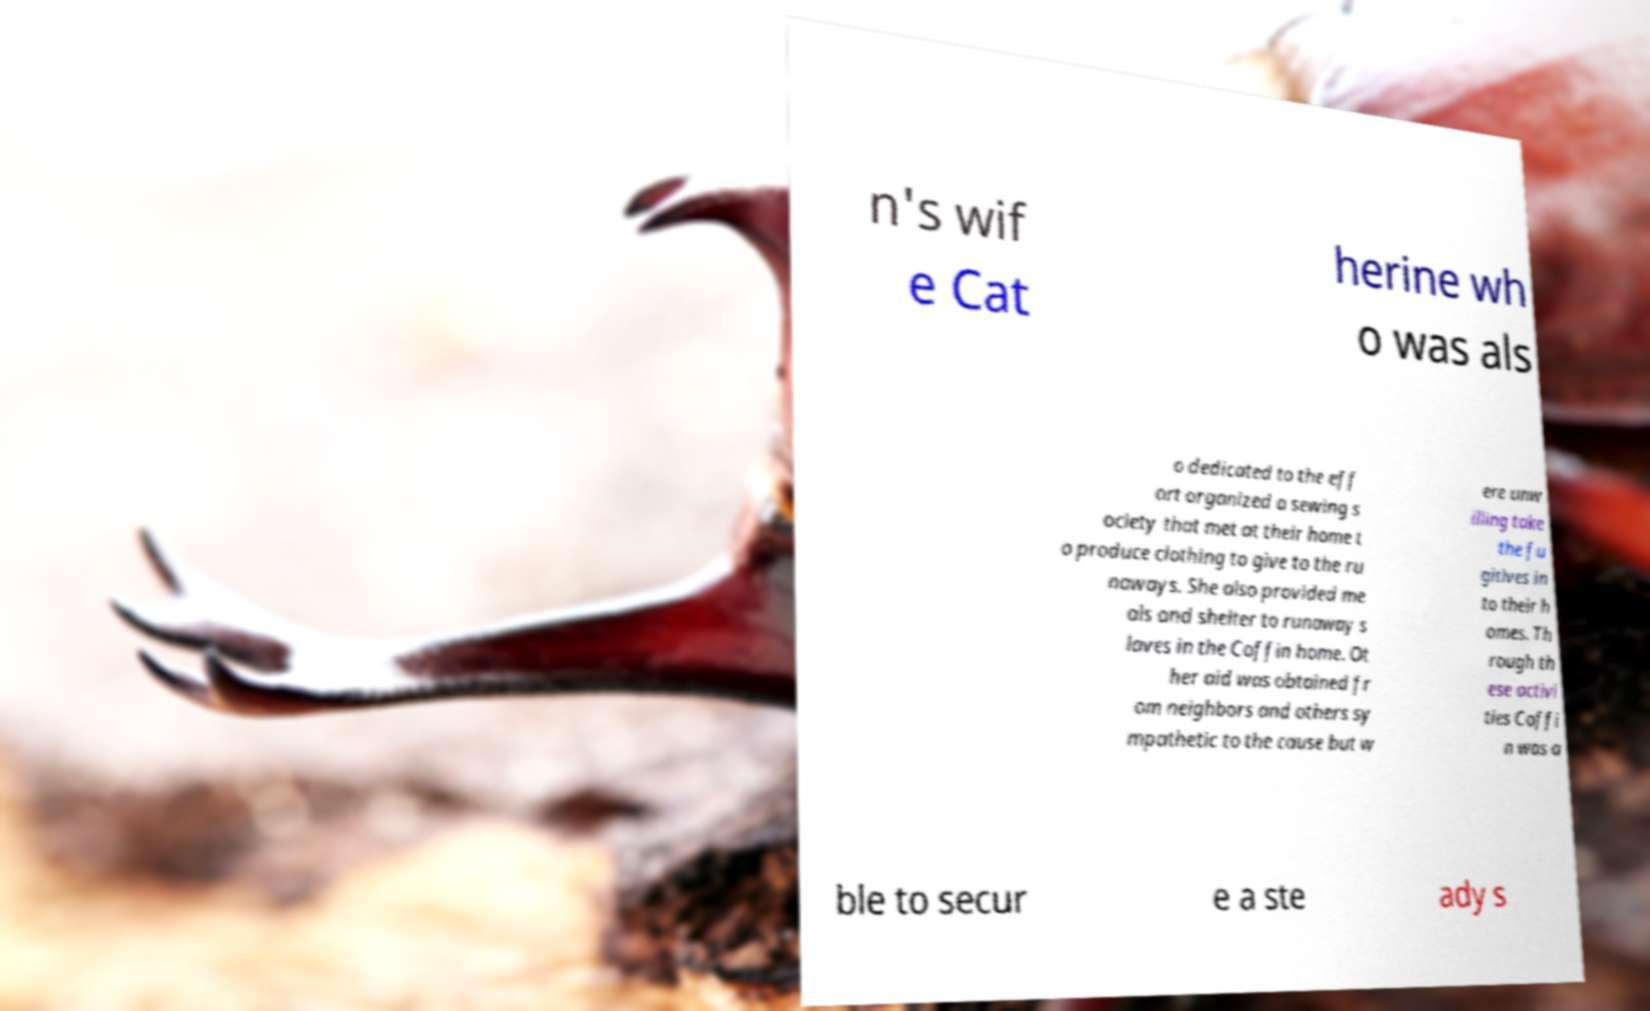Can you accurately transcribe the text from the provided image for me? n's wif e Cat herine wh o was als o dedicated to the eff ort organized a sewing s ociety that met at their home t o produce clothing to give to the ru naways. She also provided me als and shelter to runaway s laves in the Coffin home. Ot her aid was obtained fr om neighbors and others sy mpathetic to the cause but w ere unw illing take the fu gitives in to their h omes. Th rough th ese activi ties Coffi n was a ble to secur e a ste ady s 